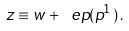Convert formula to latex. <formula><loc_0><loc_0><loc_500><loc_500>z \equiv w + \ e p ( p ^ { 1 } ) \, .</formula> 